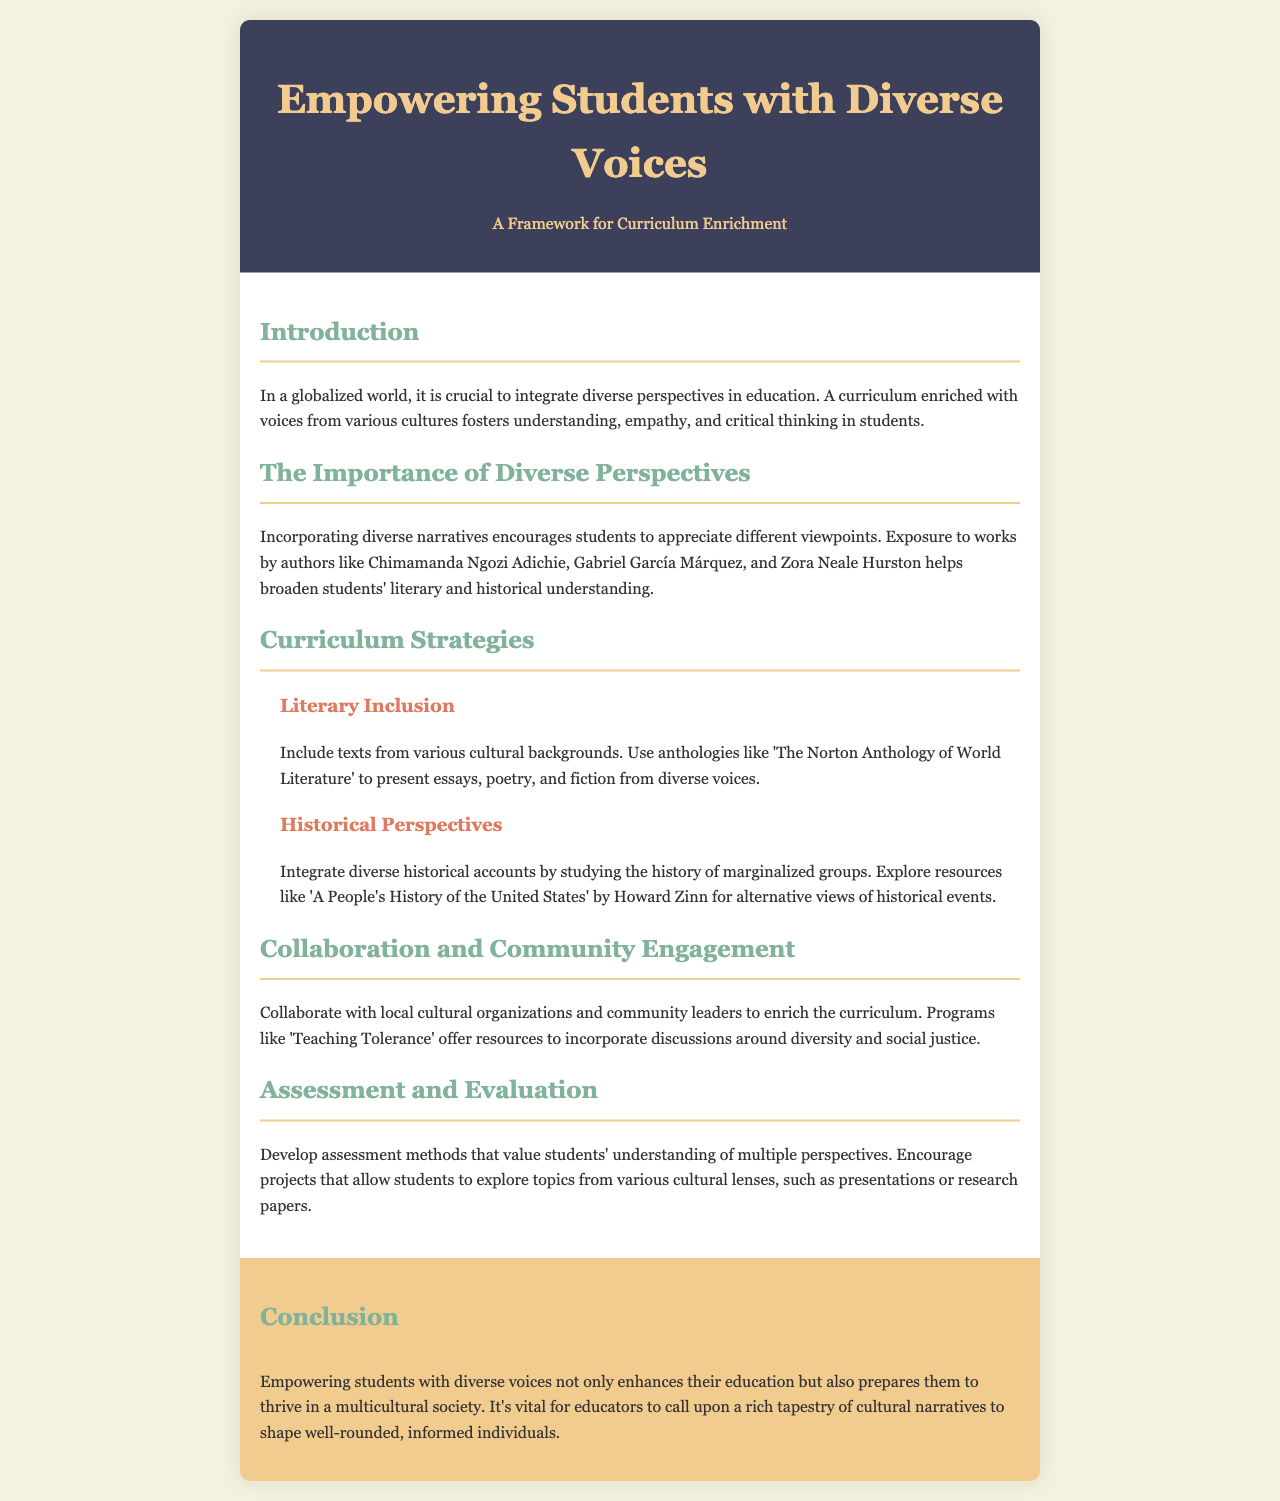What is the title of the brochure? The title of the brochure is prominently displayed at the top of the document.
Answer: Empowering Students with Diverse Voices Who is the author of 'A People's History of the United States'? The document cites Howard Zinn as the author of this historical account.
Answer: Howard Zinn Which cultural organization is mentioned for collaboration? The document references a specific program designed to help incorporate discussions around diversity.
Answer: Teaching Tolerance What does the introduction suggest is crucial in education? The introduction emphasizes the importance of integrating several elements into the curriculum.
Answer: Diverse perspectives What type of texts does the brochure recommend for literary inclusion? The document recommends using a specific type of educational anthology for introducing diverse narratives.
Answer: Anthologies How does the brochure suggest students can demonstrate understanding of multiple perspectives? The document mentions a specific method for students to explore topics from various cultural lenses.
Answer: Projects What is the main goal of empowering students with diverse voices? The conclusion summarizes the overall purpose of integrating diverse narratives into education.
Answer: Well-rounded, informed individuals What major perspective shifts does the brochure encourage in history classes? The document outlines the need to consider different viewpoints from historical events concerning marginalized groups.
Answer: Diverse historical accounts What are students encouraged to explore through presentations or research papers? This section of the document focuses on projects allowing students to delve into several cultural narratives.
Answer: Topics from various cultural lenses 